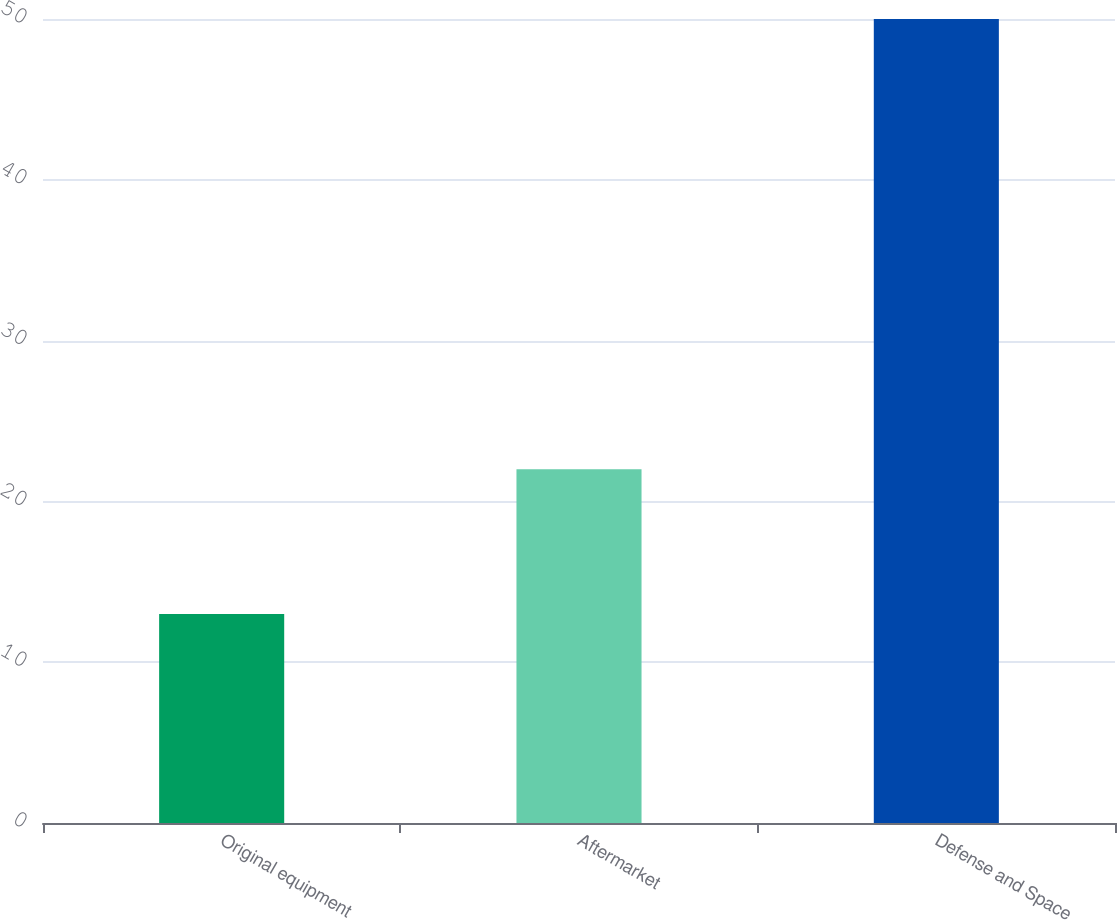Convert chart to OTSL. <chart><loc_0><loc_0><loc_500><loc_500><bar_chart><fcel>Original equipment<fcel>Aftermarket<fcel>Defense and Space<nl><fcel>13<fcel>22<fcel>50<nl></chart> 